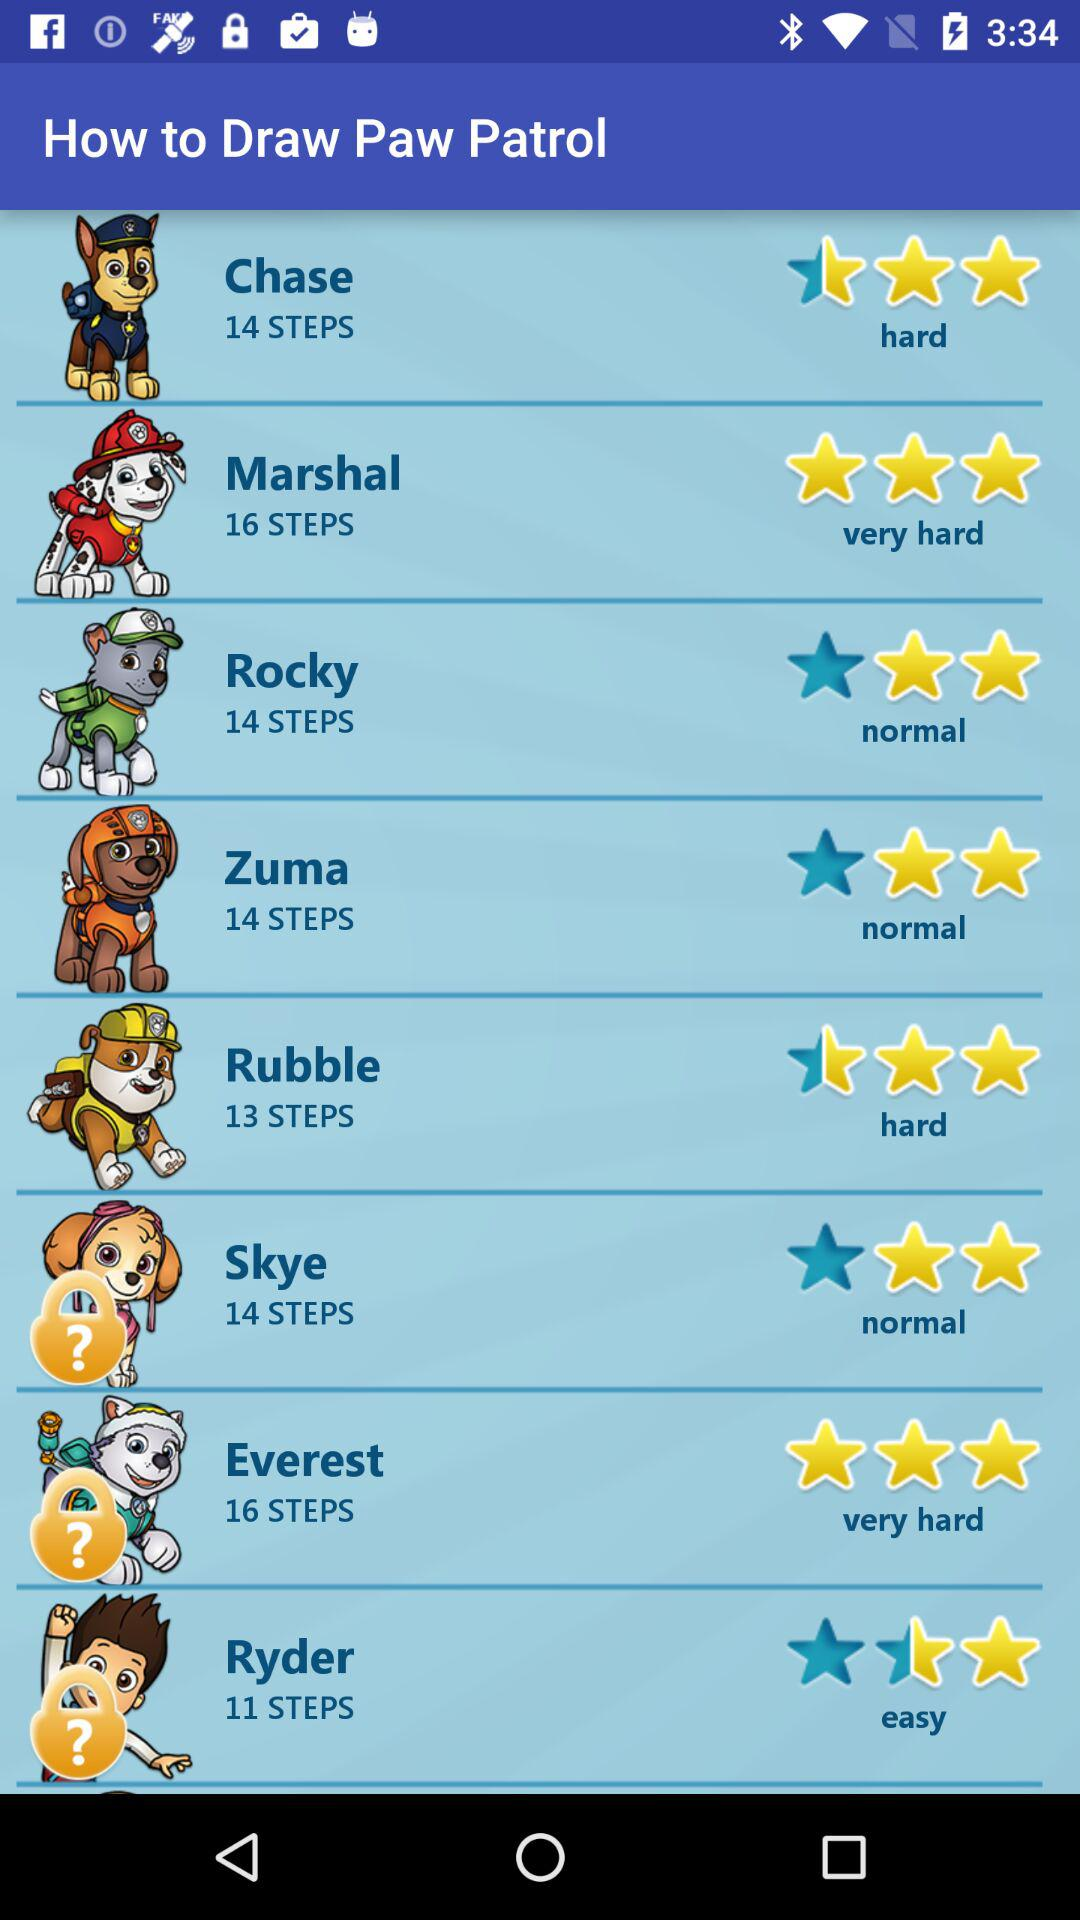How many steps are required to draw Ryder? There are 11 steps required to draw Ryder. 